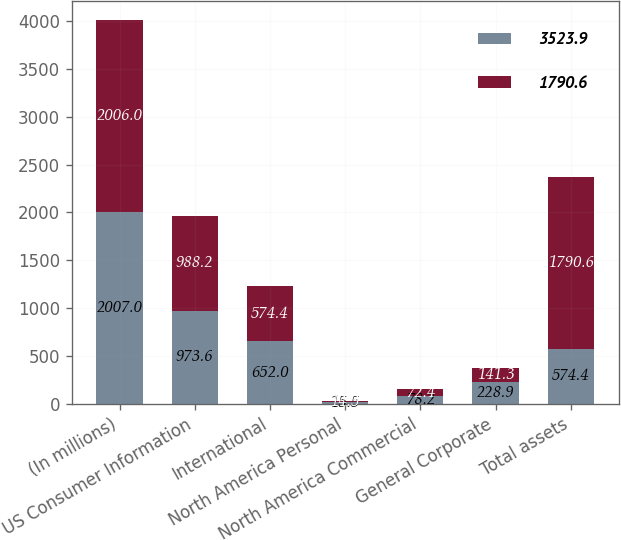Convert chart. <chart><loc_0><loc_0><loc_500><loc_500><stacked_bar_chart><ecel><fcel>(In millions)<fcel>US Consumer Information<fcel>International<fcel>North America Personal<fcel>North America Commercial<fcel>General Corporate<fcel>Total assets<nl><fcel>3523.9<fcel>2007<fcel>973.6<fcel>652<fcel>15.5<fcel>78.2<fcel>228.9<fcel>574.4<nl><fcel>1790.6<fcel>2006<fcel>988.2<fcel>574.4<fcel>14.3<fcel>72.4<fcel>141.3<fcel>1790.6<nl></chart> 